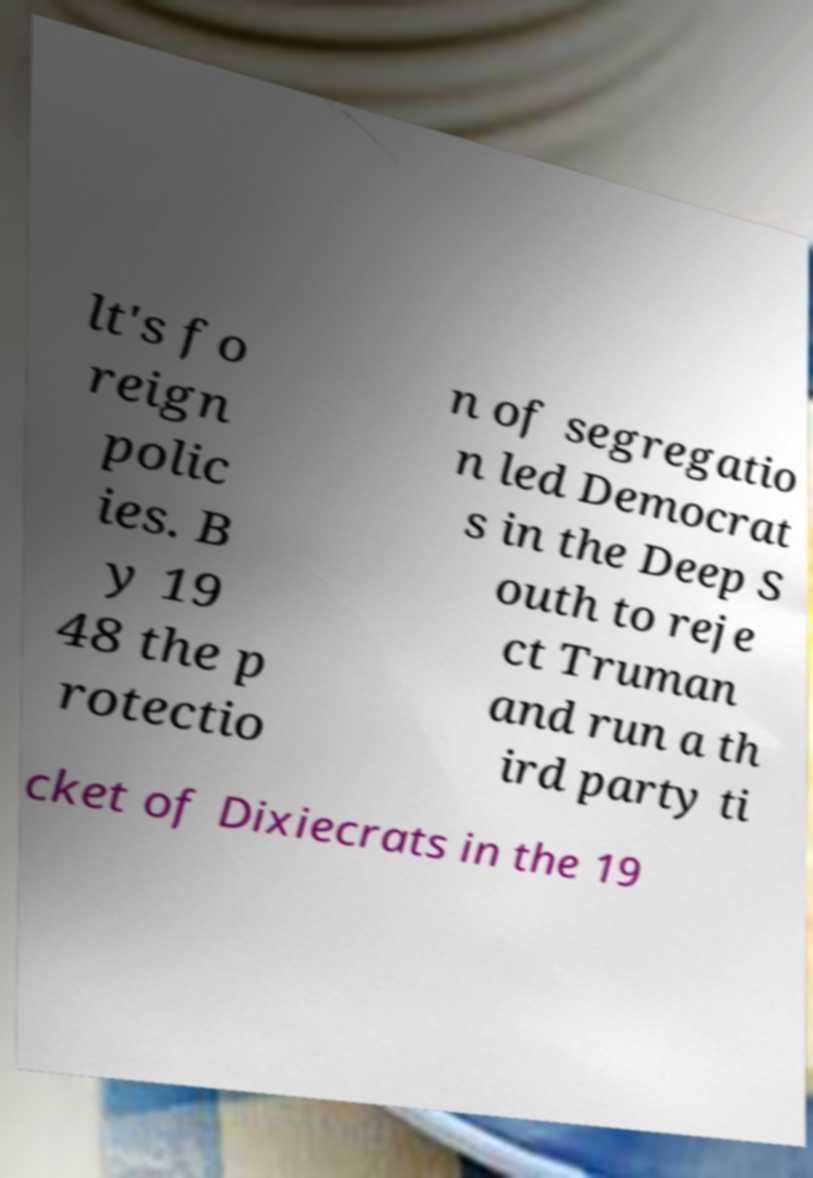For documentation purposes, I need the text within this image transcribed. Could you provide that? lt's fo reign polic ies. B y 19 48 the p rotectio n of segregatio n led Democrat s in the Deep S outh to reje ct Truman and run a th ird party ti cket of Dixiecrats in the 19 